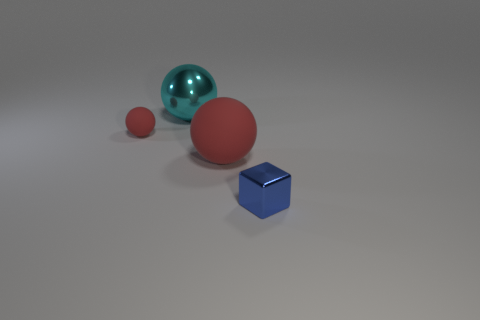There is a block that is the same material as the cyan object; what is its size?
Your answer should be compact. Small. Is the shape of the tiny thing behind the big red matte sphere the same as the shiny thing left of the shiny block?
Give a very brief answer. Yes. The cube that is the same material as the big cyan object is what color?
Offer a terse response. Blue. There is a rubber sphere right of the big cyan ball; is its size the same as the shiny thing behind the tiny blue metal thing?
Give a very brief answer. Yes. What shape is the object that is both on the left side of the tiny blue thing and on the right side of the large shiny ball?
Keep it short and to the point. Sphere. Is there a blue block made of the same material as the cyan ball?
Your answer should be very brief. Yes. There is a sphere that is the same color as the small matte object; what is its material?
Give a very brief answer. Rubber. Do the red object that is left of the big rubber object and the red sphere that is on the right side of the metallic ball have the same material?
Make the answer very short. Yes. Is the number of large spheres greater than the number of small gray matte blocks?
Your response must be concise. Yes. The tiny object that is to the right of the cyan object right of the red rubber ball that is behind the big red matte sphere is what color?
Offer a very short reply. Blue. 